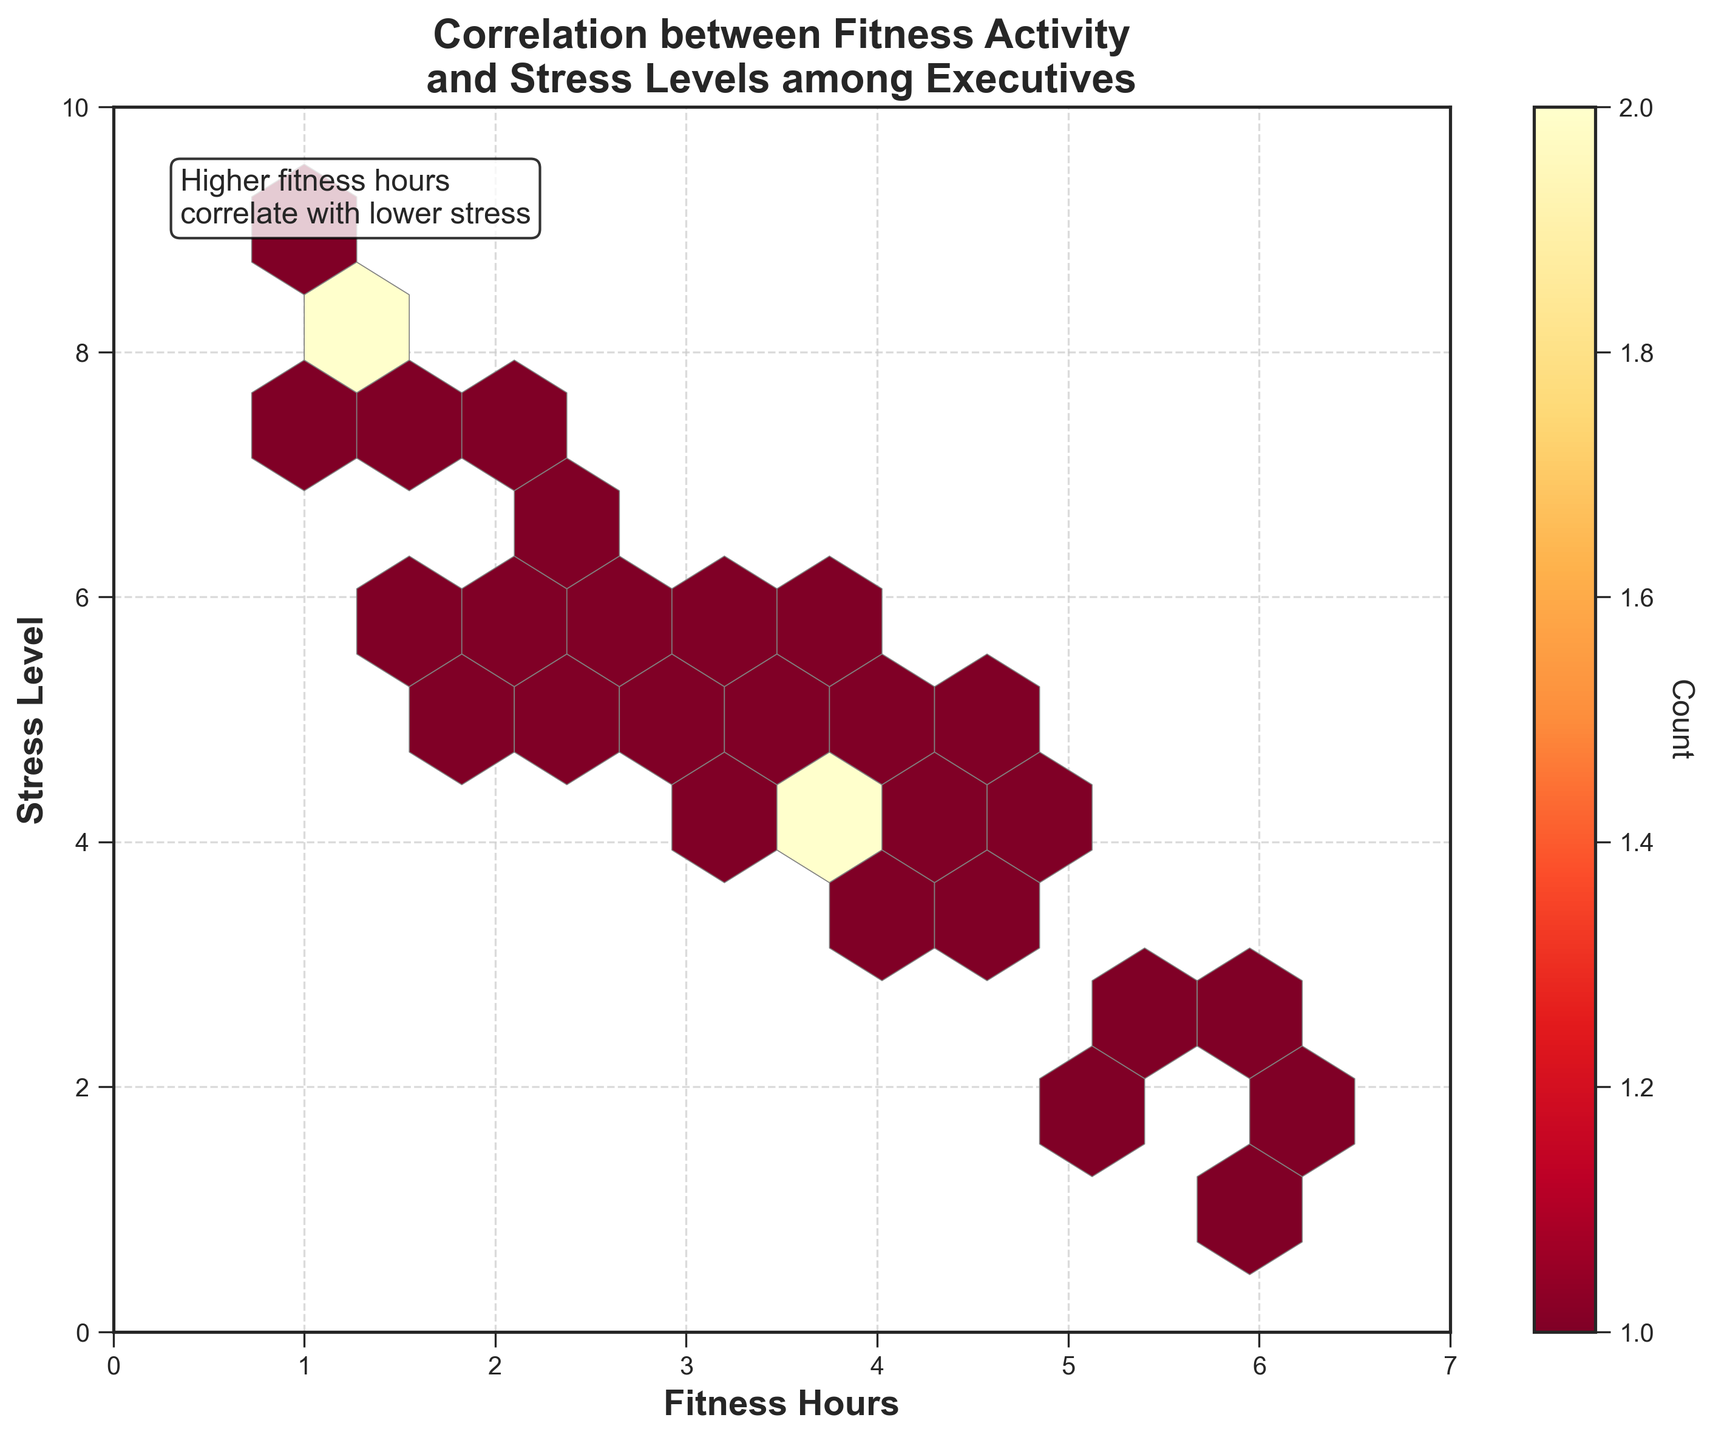What is the title of the plot? The title is located at the top of the plot. It reads "Correlation between Fitness Activity and Stress Levels among Executives."
Answer: Correlation between Fitness Activity and Stress Levels among Executives What are the labels for the X and Y axes? The X-axis and Y-axis labels are located next to their respective axes. The X-axis is labeled "Fitness Hours" and the Y-axis is labeled "Stress Level."
Answer: Fitness Hours and Stress Level What is the color of the hexagons with the highest concentration? The color of the hexagons with the highest concentration can be determined by looking at the color bar on the right side of the plot, which shows the count. The hexagons with the highest concentration are in a darker shade of red.
Answer: Darker shade of red What does the text box at the top left of the plot mention? The text box located at the top left corner of the plot contains a note stating "Higher fitness hours correlate with lower stress."
Answer: Higher fitness hours correlate with lower stress What is the range of fitness hours displayed on the X-axis? The range of fitness hours can be observed from the limits of the X-axis. The axis ranges from 0 to 7 hours.
Answer: 0 to 7 hours How many data points fell into the hexagon with the highest count? Look at the color bar on the right side of the plot and match the darkest shade of red in the plot to the count on the color bar. The highest count hexagon corresponds to the darkest red, which indicates a count of about 3.
Answer: 3 How does the density of hexagons vary with fitness hours and stress levels? Observing the plot, the hexagons become denser at lower stress levels (around 2 to 5) for higher fitness hours (3 to 6 hours). This suggests more data points are concentrated in these areas.
Answer: Denser at lower stress levels for higher fitness hours What can you infer about the relationship between fitness hours and stress levels? The plot and the concentration of hexagons indicate that with an increase in fitness hours, the stress levels among executives tend to decrease, as shown by higher data point concentrations in areas with higher fitness hours and lower stress levels.
Answer: Increased fitness hours correlate with decreased stress levels Which fitness hour value has the most diversified stress level ranges? Observing the hexagonal concentration vertically along fitness hour values, around the value of 2.5 to 3.0 fitness hours, stress levels range from approximately 5 to 7, indicating a diversified range of stress levels for these fitness hours.
Answer: 2.5 to 3.0 Is there a fitness hour range where no stress level data is available? By observing the plot, especially the region from 0 to 1 hours of fitness, there are no hexagons (indicating data points) in those regions. Similarly, for stress levels above 9 and below 1, there are no data points available.
Answer: 0 to 1 hours of fitness and stress levels above 9 and below 1 